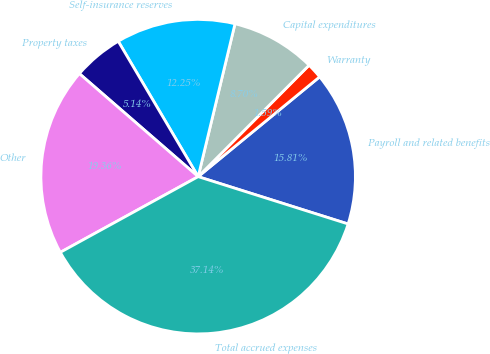Convert chart to OTSL. <chart><loc_0><loc_0><loc_500><loc_500><pie_chart><fcel>Payroll and related benefits<fcel>Warranty<fcel>Capital expenditures<fcel>Self-insurance reserves<fcel>Property taxes<fcel>Other<fcel>Total accrued expenses<nl><fcel>15.81%<fcel>1.59%<fcel>8.7%<fcel>12.25%<fcel>5.14%<fcel>19.36%<fcel>37.14%<nl></chart> 